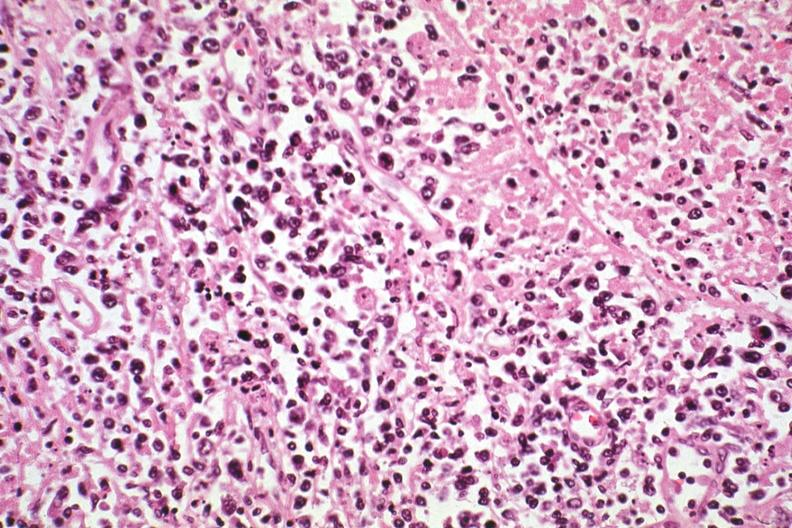what does hodgkins see?
Answer the question using a single word or phrase. Other slides in file 